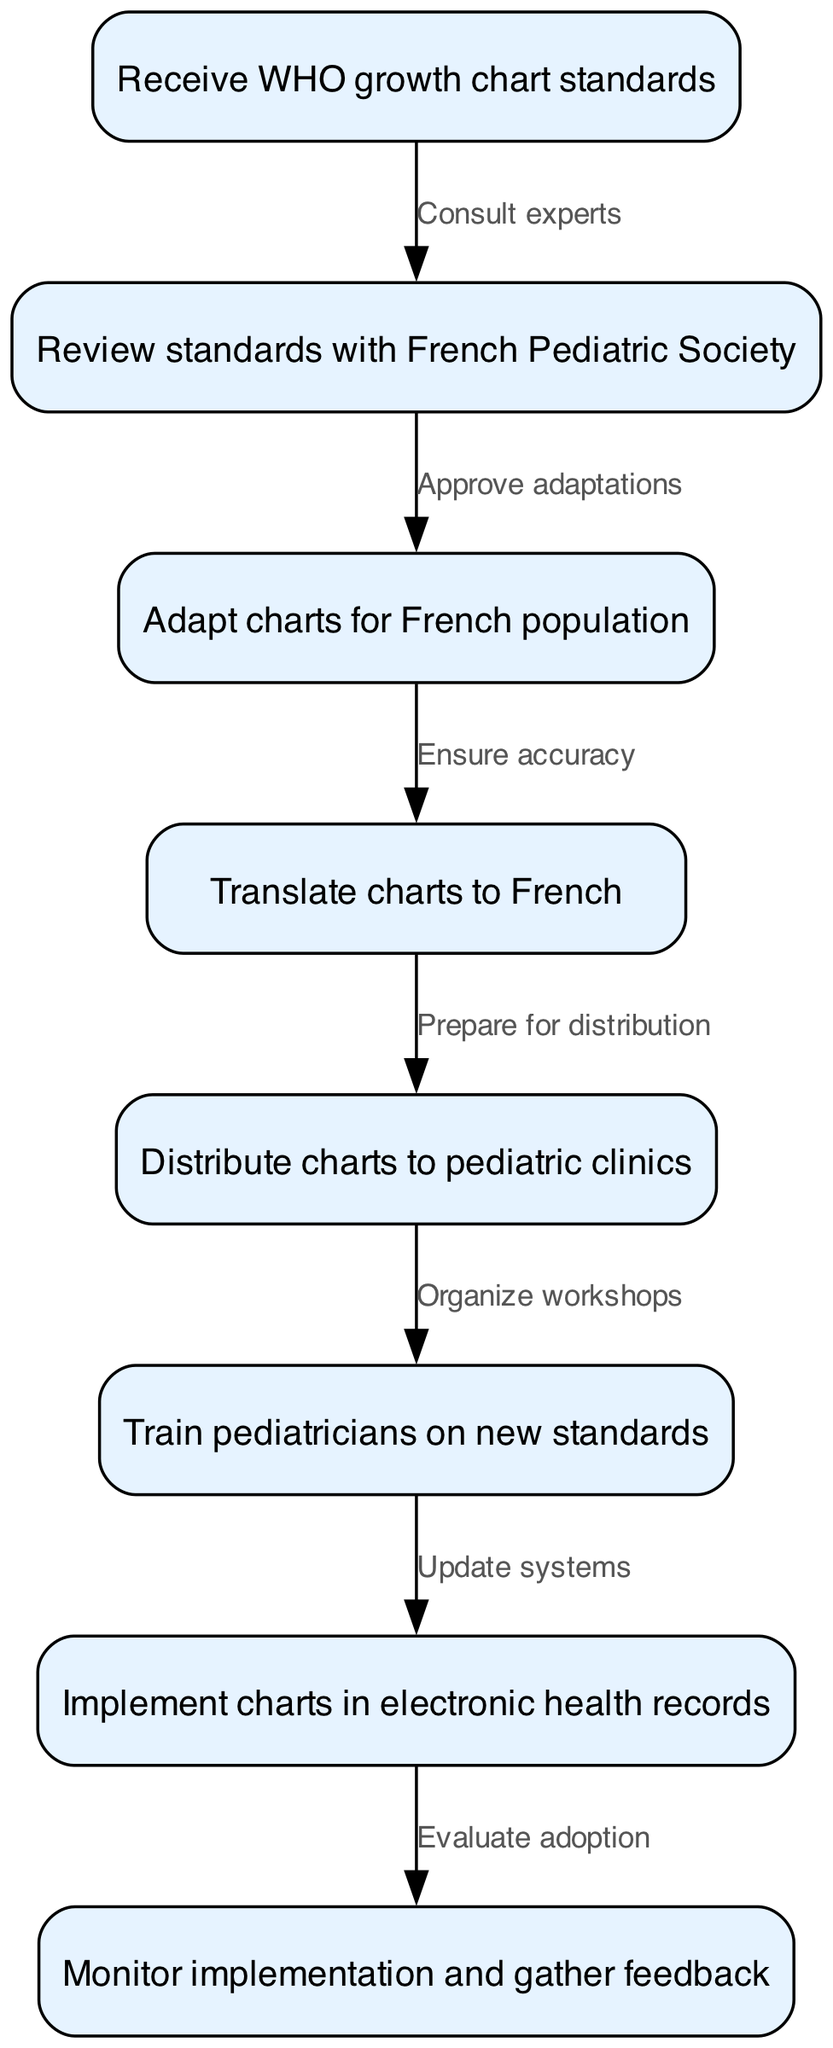What is the first step in implementing the new WHO growth chart standards? The diagram starts with the node labeled "Receive WHO growth chart standards," indicating that this is the initial step in the process.
Answer: Receive WHO growth chart standards How many nodes are present in the diagram? The diagram contains eight nodes, which are visually represented as distinct steps in the implementation process.
Answer: 8 What action follows the "Adapt charts for French population"? The flow in the diagram indicates that after the adaptation of charts, the next step is "Translate charts to French," showing a direct connection between these two actions.
Answer: Translate charts to French What is the purpose of the edge labeled "Approve adaptations"? The edge labeled "Approve adaptations" connects the nodes "Review standards with French Pediatric Society" and "Adapt charts for French population," indicating that this action is necessary for validating how the charts will be adapted.
Answer: Approve adaptations Which step involves training pediatricians? The node titled "Train pediatricians on new standards" represents the specific step in which pediatricians are informed and trained about the new growth chart standards.
Answer: Train pediatricians on new standards What comes before the "Implement charts in electronic health records"? According to the diagram, the step "Train pediatricians on new standards" precedes "Implement charts in electronic health records," meaning training is essential before implementation can occur.
Answer: Train pediatricians on new standards What is the last action taken in the process? The final step in the diagram is "Monitor implementation and gather feedback," indicating that this is the last action taken to ensure the effectiveness of the new standards.
Answer: Monitor implementation and gather feedback Which nodes are connected by the edge labeled "Organize workshops"? The edge "Organize workshops" connects the nodes "Distribute charts to pediatric clinics" and "Train pediatricians on new standards," showing that workshops are conducted after distributing the charts and before training the pediatricians.
Answer: Distribute charts to pediatric clinics and Train pediatricians on new standards 